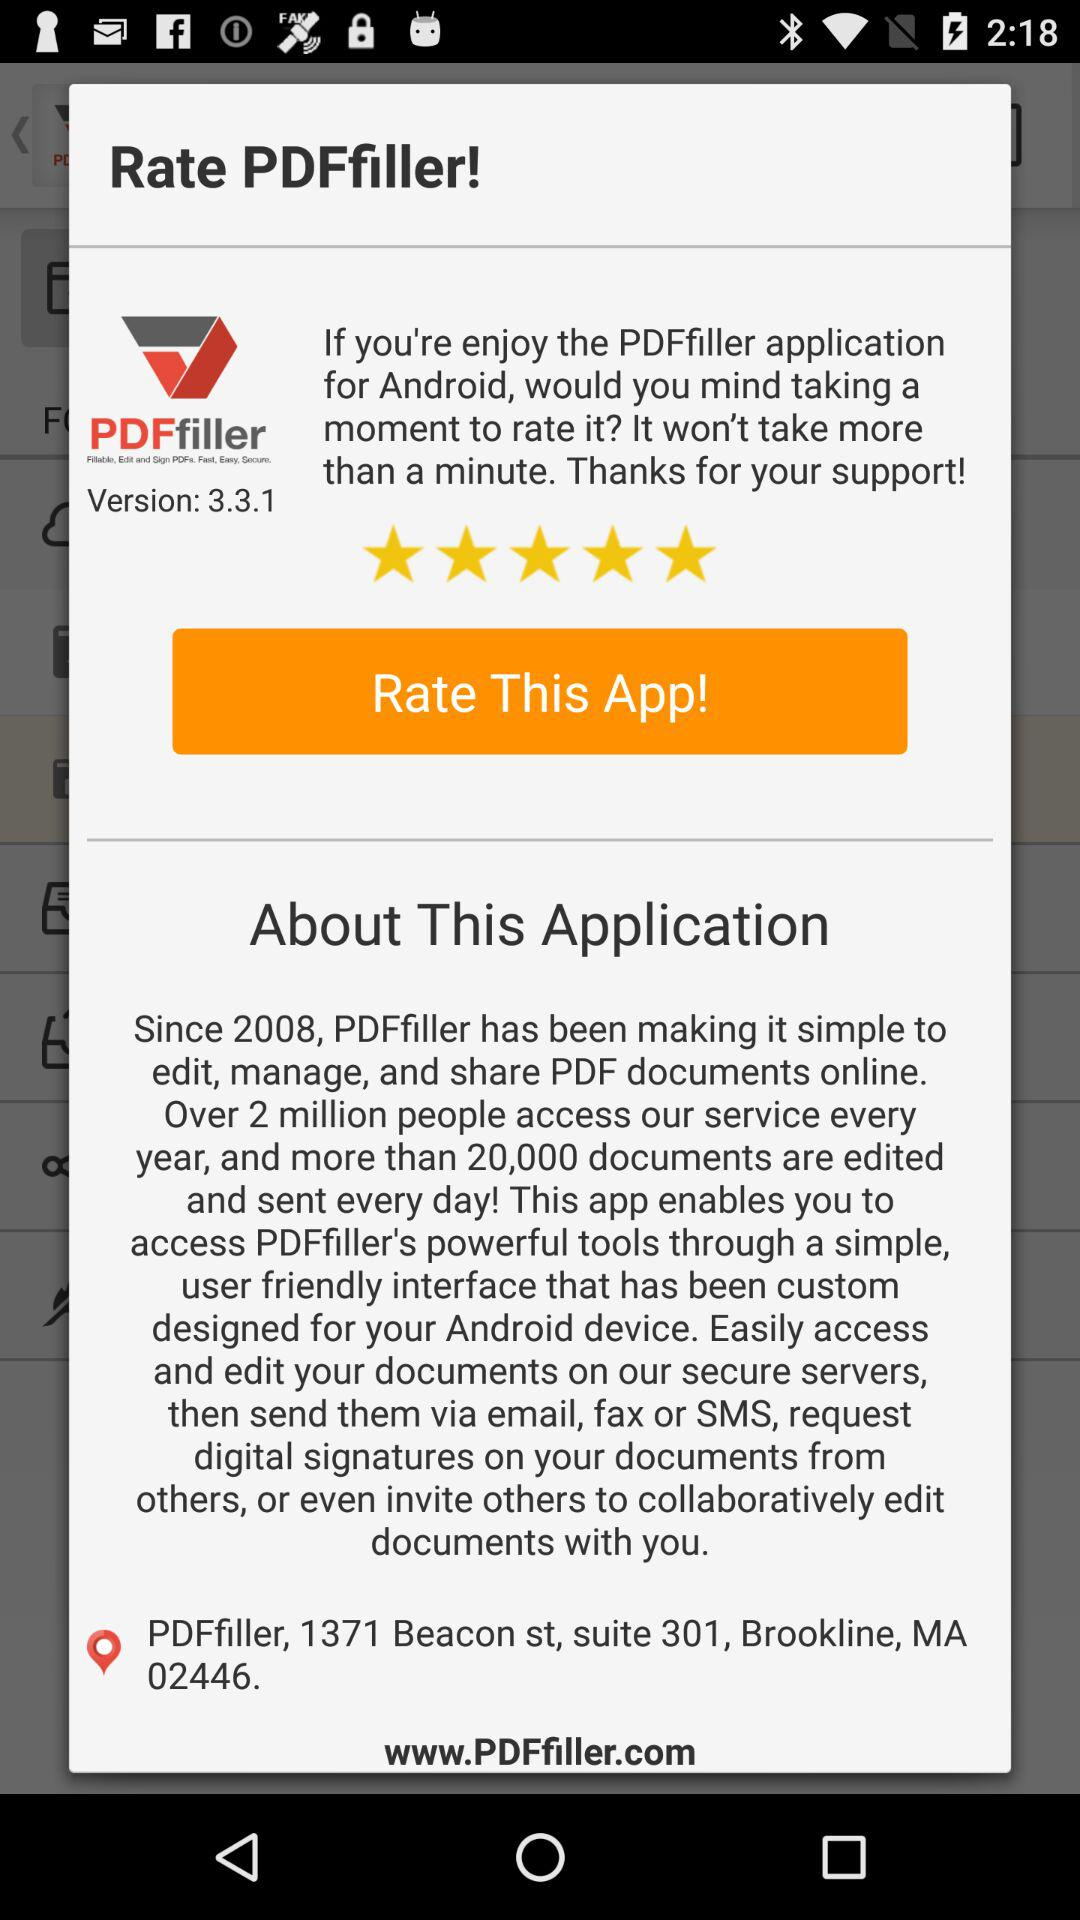How many people access the service every year?
Answer the question using a single word or phrase. Over 2 million 